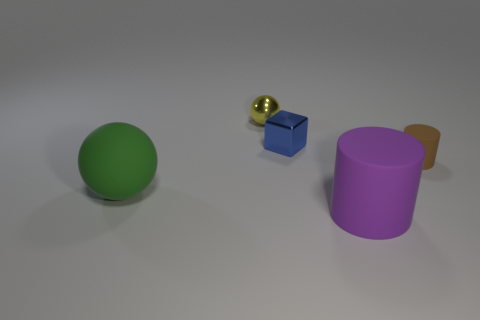Add 4 tiny metal balls. How many objects exist? 9 Add 3 matte cylinders. How many matte cylinders exist? 5 Subtract 0 gray cylinders. How many objects are left? 5 Subtract all cubes. How many objects are left? 4 Subtract all big rubber cylinders. Subtract all small yellow balls. How many objects are left? 3 Add 3 yellow spheres. How many yellow spheres are left? 4 